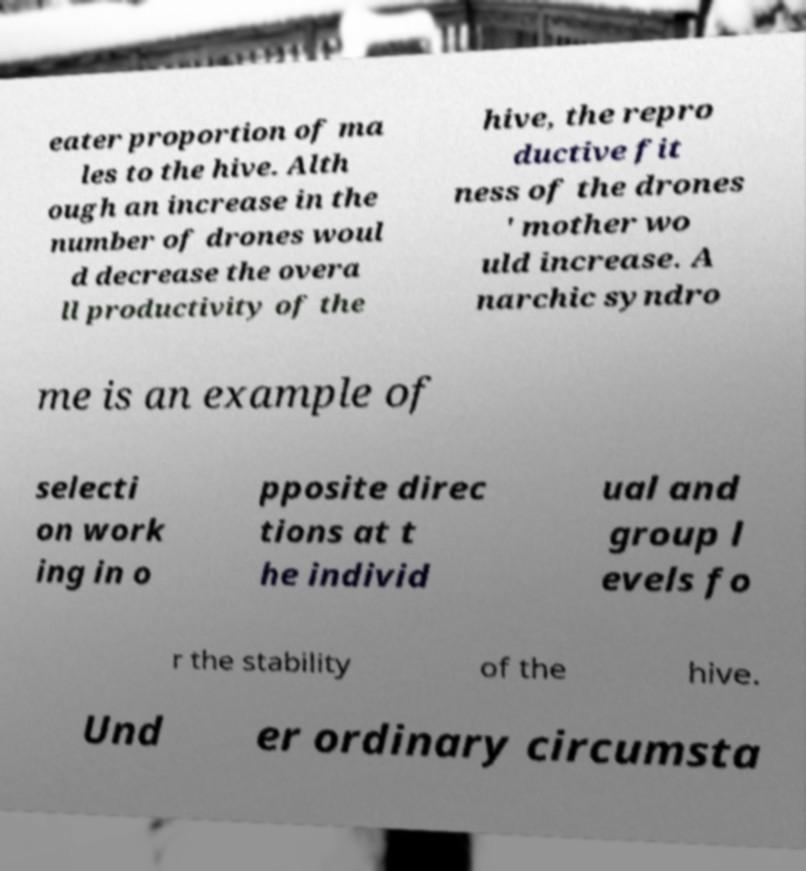For documentation purposes, I need the text within this image transcribed. Could you provide that? eater proportion of ma les to the hive. Alth ough an increase in the number of drones woul d decrease the overa ll productivity of the hive, the repro ductive fit ness of the drones ' mother wo uld increase. A narchic syndro me is an example of selecti on work ing in o pposite direc tions at t he individ ual and group l evels fo r the stability of the hive. Und er ordinary circumsta 